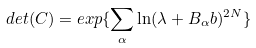Convert formula to latex. <formula><loc_0><loc_0><loc_500><loc_500>d e t ( C ) = e x p \{ \sum _ { \alpha } \ln ( \lambda + B _ { \alpha } b ) ^ { 2 N } \}</formula> 